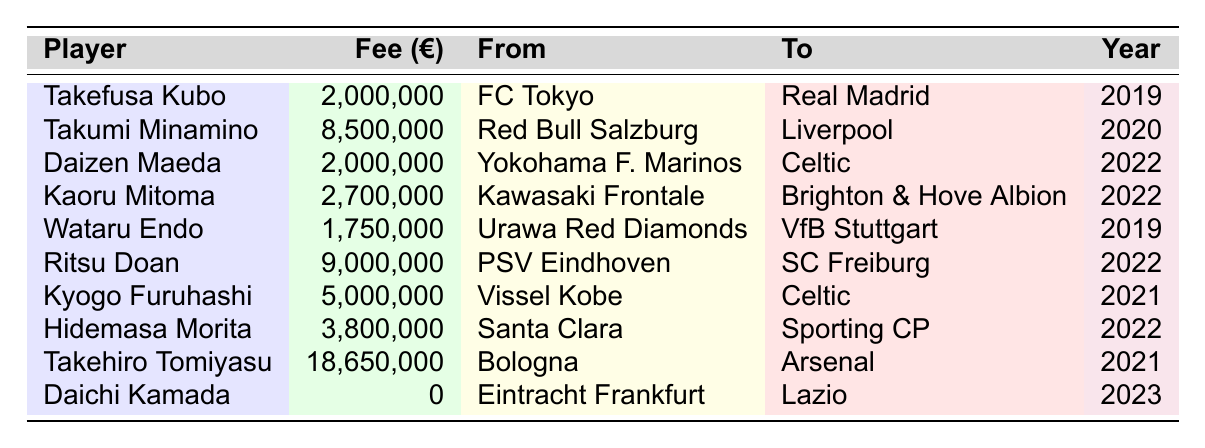What is the highest transfer fee for a Japanese player listed in the table? The table shows various players and their transfer fees. By examining the fees, the highest one is 18,650,000 euros for Takehiro Tomiyasu.
Answer: 18,650,000 Which player was transferred to Liverpool and for what fee? According to the table, Takumi Minamino was transferred to Liverpool for a fee of 8,500,000 euros.
Answer: Takumi Minamino, 8,500,000 How many players were transferred in the year 2022? Looking at the "Year" column, there are four players listed for the year 2022: Daizen Maeda, Kaoru Mitoma, Ritsu Doan, and Hidemasa Morita.
Answer: 4 What is the total transfer fee for players moving to Celtic? The transfer fees for the players moving to Celtic are Daizen Maeda (2,000,000) and Kyogo Furuhashi (5,000,000). Summing these gives 2,000,000 + 5,000,000 = 7,000,000 euros.
Answer: 7,000,000 Is there a player who was transferred for free? By checking the transfer fees, Daichi Kamada has a fee listed as 0, indicating he was transferred for free.
Answer: Yes Which player moved from Bologna to Arsenal, and what was the fee? The table indicates Takehiro Tomiyasu moved from Bologna to Arsenal for a fee of 18,650,000 euros.
Answer: Takehiro Tomiyasu, 18,650,000 What is the average transfer fee for the players listed in the table? Summing all transfer fees: 2,000,000 + 8,500,000 + 2,000,000 + 2,700,000 + 1,750,000 + 9,000,000 + 5,000,000 + 3,800,000 + 18,650,000 + 0 = 53,900,000 euros. There are ten players, so the average is 53,900,000 / 10 = 5,390,000 euros.
Answer: 5,390,000 Who had the lowest transfer fee, and what was it? From the table, Daichi Kamada has a transfer fee of 0, which is the lowest among all listed players.
Answer: Daichi Kamada, 0 How many players moved to clubs in the UK, and who are they? The players who moved to UK clubs are Takumi Minamino (Liverpool), Daizen Maeda (Celtic), Kaoru Mitoma (Brighton & Hove Albion), and Kyogo Furuhashi (Celtic). This totals four players.
Answer: 4 players: Takumi Minamino, Daizen Maeda, Kaoru Mitoma, Kyogo Furuhashi What was the transfer fee difference between Ritsu Doan and Wataru Endo? Ritsu Doan's fee is 9,000,000 euros, and Wataru Endo's fee is 1,750,000 euros. The difference is calculated as 9,000,000 - 1,750,000 = 7,250,000 euros.
Answer: 7,250,000 